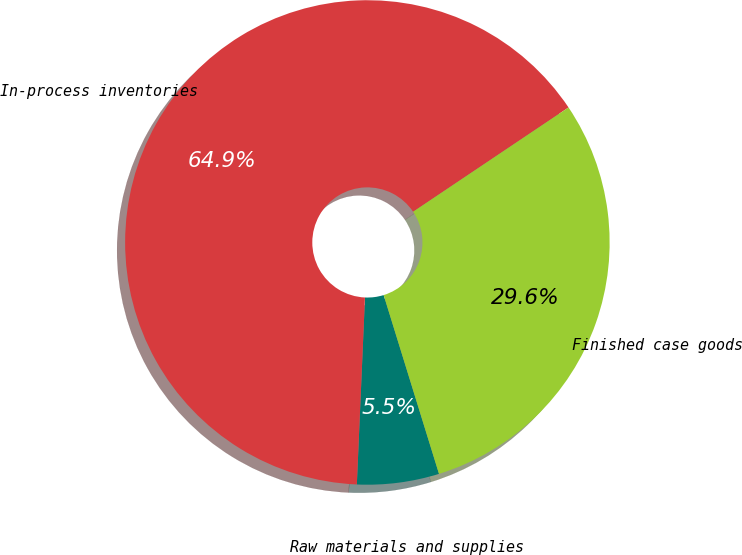Convert chart. <chart><loc_0><loc_0><loc_500><loc_500><pie_chart><fcel>Raw materials and supplies<fcel>In-process inventories<fcel>Finished case goods<nl><fcel>5.47%<fcel>64.9%<fcel>29.63%<nl></chart> 